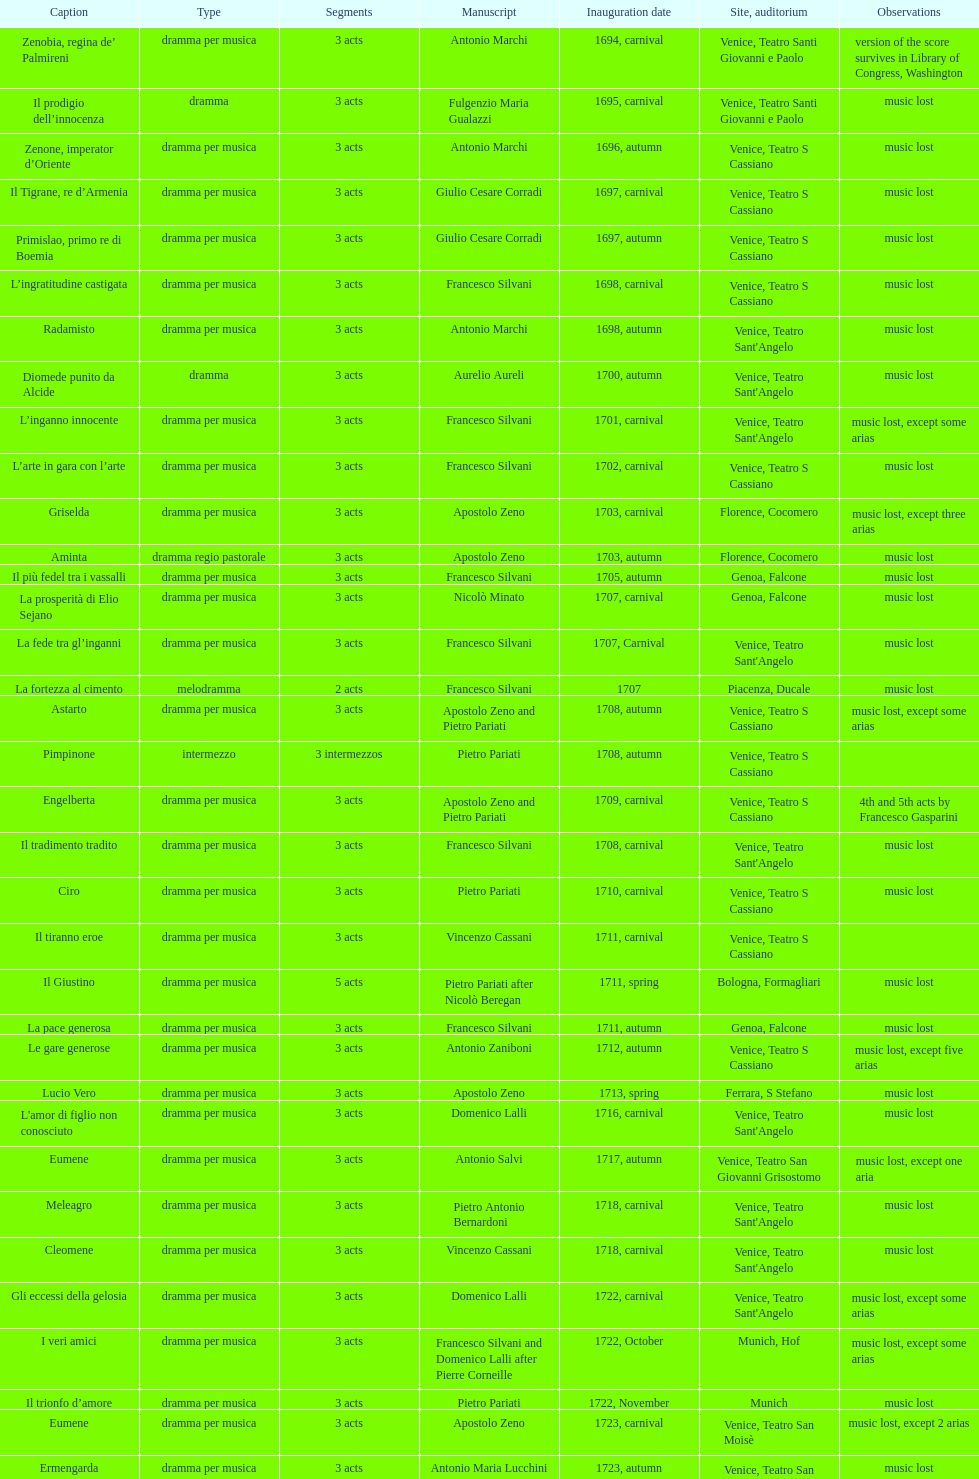Which opera has at least 5 acts? Il Giustino. 